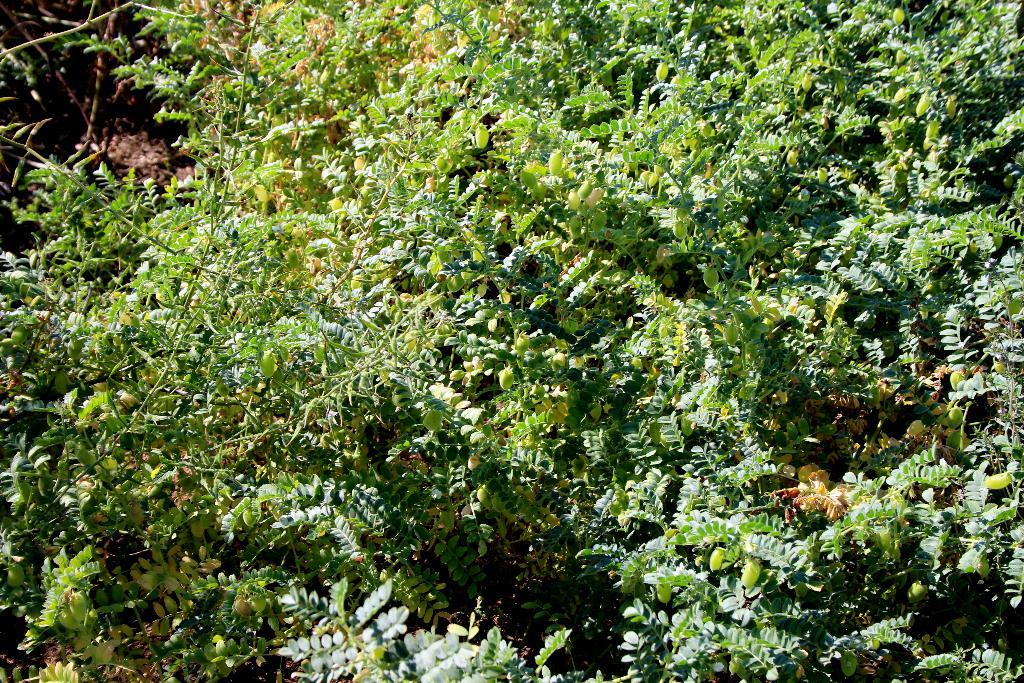What type of vegetation can be seen in the image? There are trees in the image. Can you describe the trees in the image? Unfortunately, the provided facts do not include any details about the trees, so we cannot describe them further. What might be the purpose of including trees in the image? The presence of trees in the image could suggest a natural or outdoor setting. What is the digestion process of the trees in the image? Trees do not have a digestion process like animals or humans, as they produce their own food through photosynthesis. 